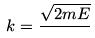<formula> <loc_0><loc_0><loc_500><loc_500>k = \frac { \sqrt { 2 m E } } { }</formula> 